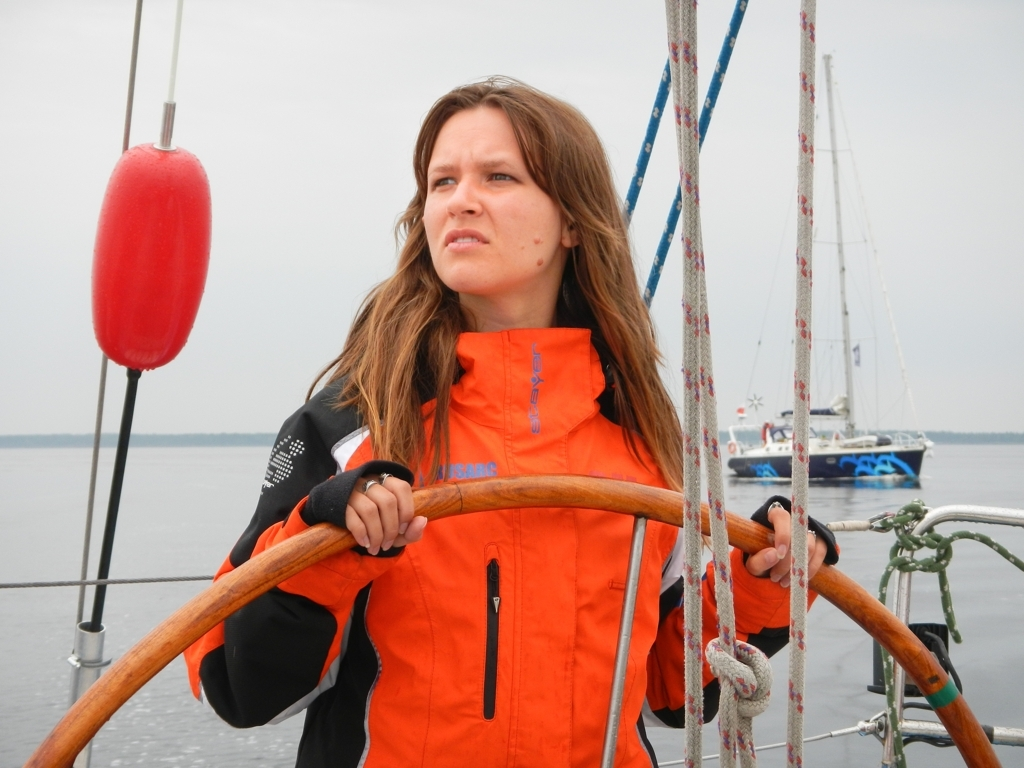Does the image have any color distortion?
 No 